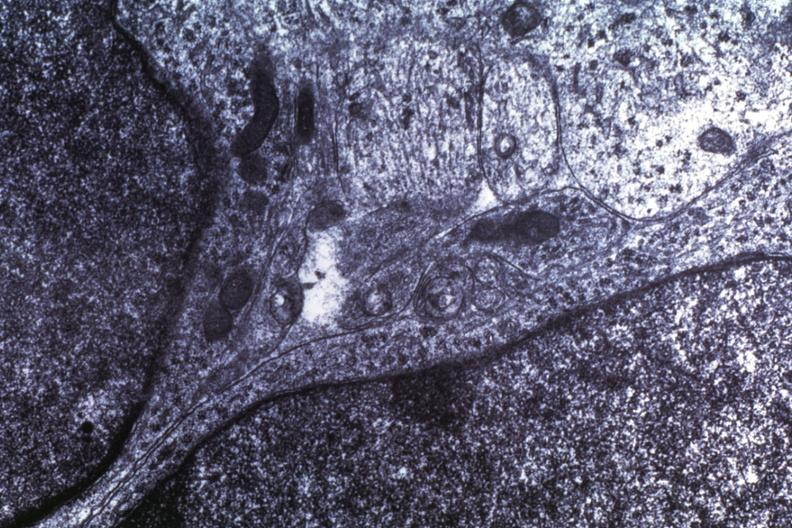what is present?
Answer the question using a single word or phrase. Brain 